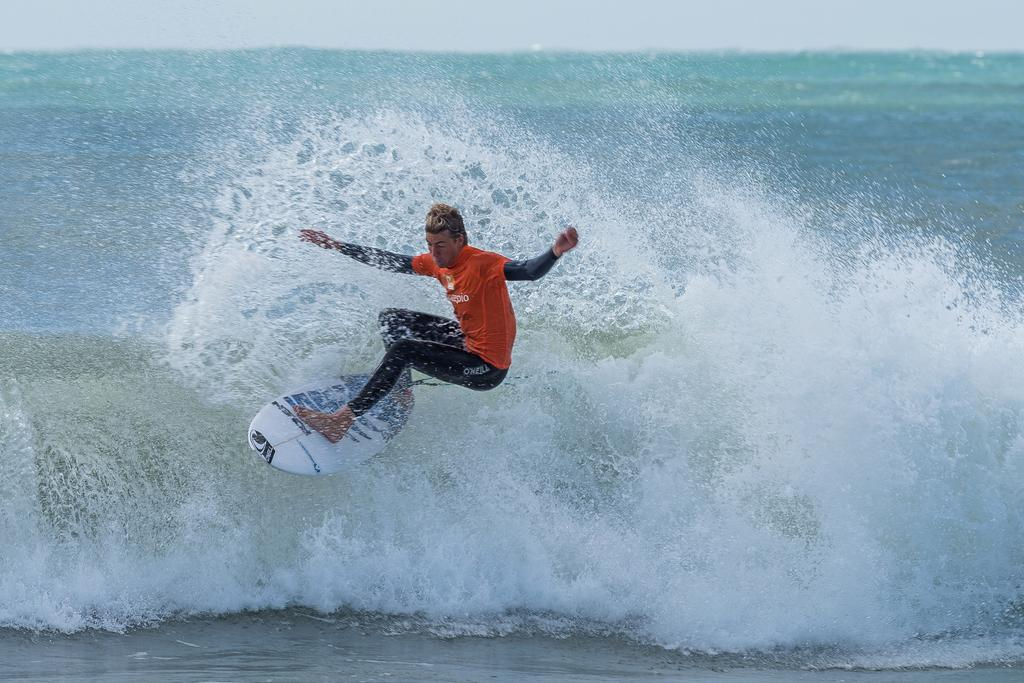<image>
Provide a brief description of the given image. A man surfs with O'neill on his black pants. 